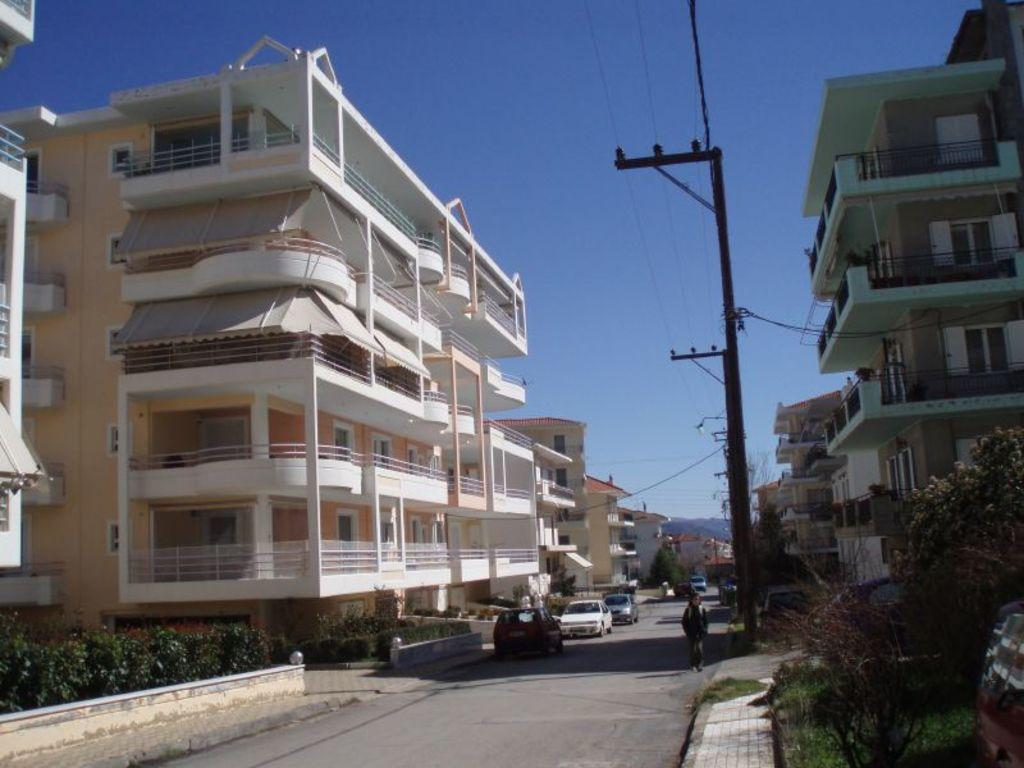What type of structures can be seen in the image? There are buildings in the image. What is moving on the road in the image? Motor vehicles are present on the road. What are the vertical structures supporting the electric cables in the image? Electric poles are visible in the image. What are the cables connected to in the image? Electric cables are present in the image. What is the person on the road doing in the image? There is a person on the road, but their activity is not specified. What type of vegetation is present near the buildings in the image? Bushes and plants are visible in the image. What type of tall vegetation is present in the image? Trees are present in the image. What is visible in the background of the image? The sky is visible in the background of the image. What type of coat is the person wearing in the image? There is no person wearing a coat in the image; the person's clothing is not specified. What type of feather can be seen falling from the sky in the image? There are no feathers falling from the sky in the image. What type of rake is being used to clean the road in the image? There is no rake present in the image; the person's activity is not specified. 